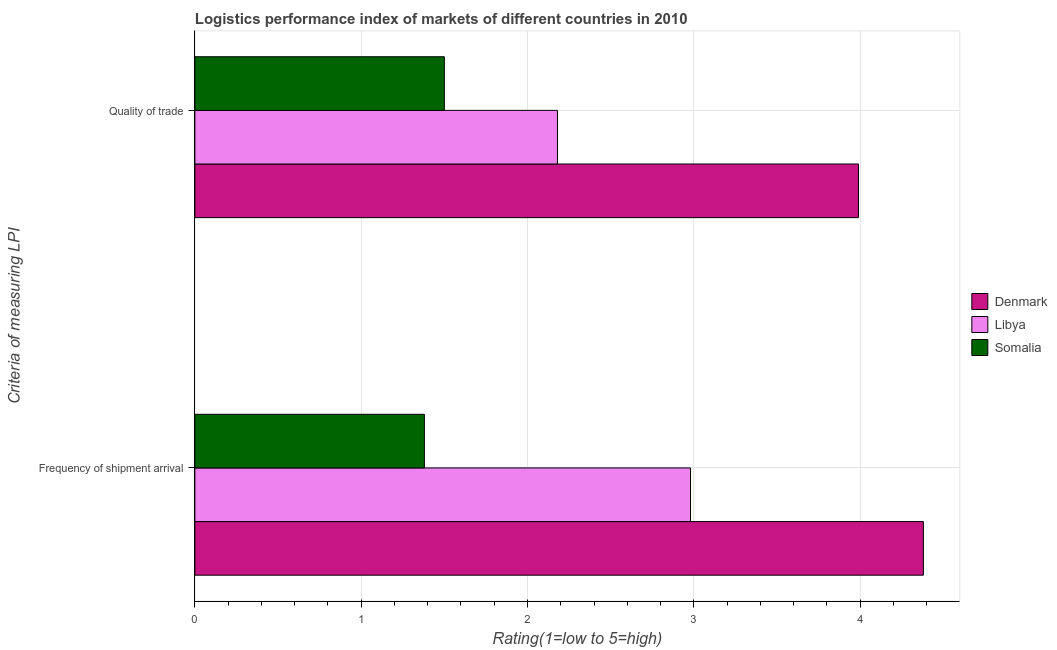Are the number of bars per tick equal to the number of legend labels?
Offer a terse response. Yes. How many bars are there on the 1st tick from the bottom?
Offer a terse response. 3. What is the label of the 1st group of bars from the top?
Keep it short and to the point. Quality of trade. What is the lpi quality of trade in Libya?
Your answer should be very brief. 2.18. Across all countries, what is the maximum lpi of frequency of shipment arrival?
Offer a very short reply. 4.38. Across all countries, what is the minimum lpi of frequency of shipment arrival?
Your answer should be compact. 1.38. In which country was the lpi of frequency of shipment arrival minimum?
Provide a succinct answer. Somalia. What is the total lpi of frequency of shipment arrival in the graph?
Keep it short and to the point. 8.74. What is the difference between the lpi of frequency of shipment arrival in Libya and that in Somalia?
Keep it short and to the point. 1.6. What is the difference between the lpi quality of trade in Libya and the lpi of frequency of shipment arrival in Somalia?
Make the answer very short. 0.8. What is the average lpi quality of trade per country?
Provide a short and direct response. 2.56. What is the difference between the lpi quality of trade and lpi of frequency of shipment arrival in Somalia?
Offer a terse response. 0.12. In how many countries, is the lpi of frequency of shipment arrival greater than 1.2 ?
Your answer should be very brief. 3. What is the ratio of the lpi of frequency of shipment arrival in Libya to that in Somalia?
Your response must be concise. 2.16. Is the lpi quality of trade in Denmark less than that in Libya?
Your response must be concise. No. In how many countries, is the lpi of frequency of shipment arrival greater than the average lpi of frequency of shipment arrival taken over all countries?
Keep it short and to the point. 2. What does the 2nd bar from the top in Quality of trade represents?
Give a very brief answer. Libya. What does the 3rd bar from the bottom in Frequency of shipment arrival represents?
Give a very brief answer. Somalia. Are all the bars in the graph horizontal?
Give a very brief answer. Yes. What is the difference between two consecutive major ticks on the X-axis?
Make the answer very short. 1. Are the values on the major ticks of X-axis written in scientific E-notation?
Make the answer very short. No. Does the graph contain grids?
Keep it short and to the point. Yes. How many legend labels are there?
Provide a succinct answer. 3. How are the legend labels stacked?
Offer a very short reply. Vertical. What is the title of the graph?
Provide a succinct answer. Logistics performance index of markets of different countries in 2010. What is the label or title of the X-axis?
Make the answer very short. Rating(1=low to 5=high). What is the label or title of the Y-axis?
Offer a terse response. Criteria of measuring LPI. What is the Rating(1=low to 5=high) in Denmark in Frequency of shipment arrival?
Your response must be concise. 4.38. What is the Rating(1=low to 5=high) in Libya in Frequency of shipment arrival?
Keep it short and to the point. 2.98. What is the Rating(1=low to 5=high) of Somalia in Frequency of shipment arrival?
Keep it short and to the point. 1.38. What is the Rating(1=low to 5=high) of Denmark in Quality of trade?
Your response must be concise. 3.99. What is the Rating(1=low to 5=high) of Libya in Quality of trade?
Offer a terse response. 2.18. What is the Rating(1=low to 5=high) in Somalia in Quality of trade?
Your response must be concise. 1.5. Across all Criteria of measuring LPI, what is the maximum Rating(1=low to 5=high) of Denmark?
Your response must be concise. 4.38. Across all Criteria of measuring LPI, what is the maximum Rating(1=low to 5=high) of Libya?
Offer a terse response. 2.98. Across all Criteria of measuring LPI, what is the maximum Rating(1=low to 5=high) of Somalia?
Provide a succinct answer. 1.5. Across all Criteria of measuring LPI, what is the minimum Rating(1=low to 5=high) of Denmark?
Give a very brief answer. 3.99. Across all Criteria of measuring LPI, what is the minimum Rating(1=low to 5=high) of Libya?
Your answer should be compact. 2.18. Across all Criteria of measuring LPI, what is the minimum Rating(1=low to 5=high) of Somalia?
Make the answer very short. 1.38. What is the total Rating(1=low to 5=high) of Denmark in the graph?
Your answer should be very brief. 8.37. What is the total Rating(1=low to 5=high) of Libya in the graph?
Make the answer very short. 5.16. What is the total Rating(1=low to 5=high) of Somalia in the graph?
Provide a succinct answer. 2.88. What is the difference between the Rating(1=low to 5=high) of Denmark in Frequency of shipment arrival and that in Quality of trade?
Keep it short and to the point. 0.39. What is the difference between the Rating(1=low to 5=high) of Libya in Frequency of shipment arrival and that in Quality of trade?
Make the answer very short. 0.8. What is the difference between the Rating(1=low to 5=high) of Somalia in Frequency of shipment arrival and that in Quality of trade?
Offer a very short reply. -0.12. What is the difference between the Rating(1=low to 5=high) in Denmark in Frequency of shipment arrival and the Rating(1=low to 5=high) in Libya in Quality of trade?
Provide a succinct answer. 2.2. What is the difference between the Rating(1=low to 5=high) of Denmark in Frequency of shipment arrival and the Rating(1=low to 5=high) of Somalia in Quality of trade?
Your answer should be very brief. 2.88. What is the difference between the Rating(1=low to 5=high) in Libya in Frequency of shipment arrival and the Rating(1=low to 5=high) in Somalia in Quality of trade?
Your answer should be compact. 1.48. What is the average Rating(1=low to 5=high) of Denmark per Criteria of measuring LPI?
Make the answer very short. 4.18. What is the average Rating(1=low to 5=high) of Libya per Criteria of measuring LPI?
Ensure brevity in your answer.  2.58. What is the average Rating(1=low to 5=high) in Somalia per Criteria of measuring LPI?
Provide a succinct answer. 1.44. What is the difference between the Rating(1=low to 5=high) of Denmark and Rating(1=low to 5=high) of Libya in Frequency of shipment arrival?
Give a very brief answer. 1.4. What is the difference between the Rating(1=low to 5=high) in Denmark and Rating(1=low to 5=high) in Somalia in Frequency of shipment arrival?
Your answer should be very brief. 3. What is the difference between the Rating(1=low to 5=high) of Denmark and Rating(1=low to 5=high) of Libya in Quality of trade?
Your answer should be very brief. 1.81. What is the difference between the Rating(1=low to 5=high) in Denmark and Rating(1=low to 5=high) in Somalia in Quality of trade?
Provide a succinct answer. 2.49. What is the difference between the Rating(1=low to 5=high) of Libya and Rating(1=low to 5=high) of Somalia in Quality of trade?
Make the answer very short. 0.68. What is the ratio of the Rating(1=low to 5=high) in Denmark in Frequency of shipment arrival to that in Quality of trade?
Your response must be concise. 1.1. What is the ratio of the Rating(1=low to 5=high) of Libya in Frequency of shipment arrival to that in Quality of trade?
Make the answer very short. 1.37. What is the difference between the highest and the second highest Rating(1=low to 5=high) in Denmark?
Offer a very short reply. 0.39. What is the difference between the highest and the second highest Rating(1=low to 5=high) of Somalia?
Offer a terse response. 0.12. What is the difference between the highest and the lowest Rating(1=low to 5=high) of Denmark?
Your response must be concise. 0.39. What is the difference between the highest and the lowest Rating(1=low to 5=high) in Libya?
Make the answer very short. 0.8. What is the difference between the highest and the lowest Rating(1=low to 5=high) in Somalia?
Offer a very short reply. 0.12. 